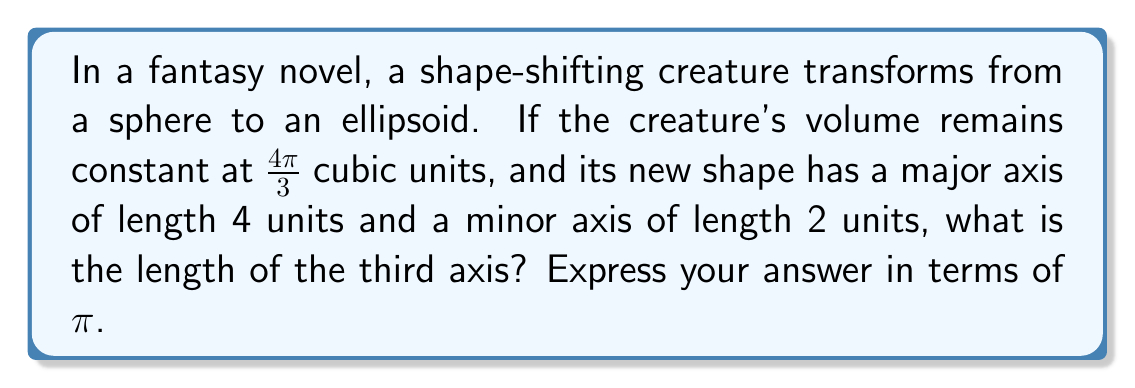Give your solution to this math problem. Let's approach this step-by-step:

1) The volume of a sphere is given by the formula:
   $$V_{sphere} = \frac{4}{3}\pi r^3$$

2) We're told that the volume is 4π/3 cubic units, so:
   $$\frac{4}{3}\pi = \frac{4}{3}\pi r^3$$
   $$r^3 = 1$$
   $$r = 1$$

3) Now, the creature transforms into an ellipsoid. The volume of an ellipsoid is given by:
   $$V_{ellipsoid} = \frac{4}{3}\pi abc$$
   where a, b, and c are the semi-axes lengths.

4) We're given that the major axis is 4 units and the minor axis is 2 units. Let's call the unknown third axis 2x. So:
   $$a = 2, b = 1, c = x$$

5) Since the volume remains constant, we can equate the volumes:
   $$\frac{4}{3}\pi = \frac{4}{3}\pi(2)(1)(x)$$

6) Simplify:
   $$1 = 2x$$
   $$x = \frac{1}{2}$$

7) Remember, x is the semi-axis length. The full axis length is 2x = 1.
Answer: 1 unit 